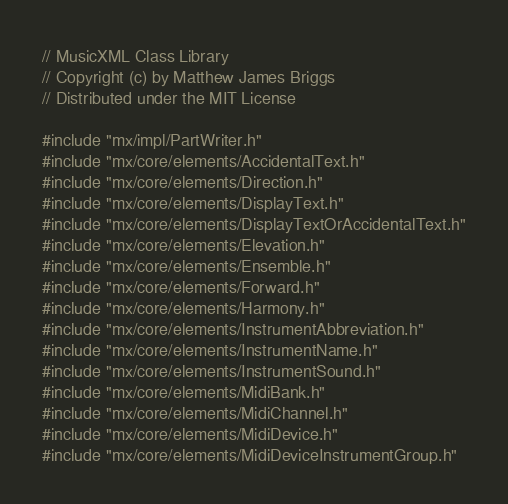<code> <loc_0><loc_0><loc_500><loc_500><_C++_>// MusicXML Class Library
// Copyright (c) by Matthew James Briggs
// Distributed under the MIT License

#include "mx/impl/PartWriter.h"
#include "mx/core/elements/AccidentalText.h"
#include "mx/core/elements/Direction.h"
#include "mx/core/elements/DisplayText.h"
#include "mx/core/elements/DisplayTextOrAccidentalText.h"
#include "mx/core/elements/Elevation.h"
#include "mx/core/elements/Ensemble.h"
#include "mx/core/elements/Forward.h"
#include "mx/core/elements/Harmony.h"
#include "mx/core/elements/InstrumentAbbreviation.h"
#include "mx/core/elements/InstrumentName.h"
#include "mx/core/elements/InstrumentSound.h"
#include "mx/core/elements/MidiBank.h"
#include "mx/core/elements/MidiChannel.h"
#include "mx/core/elements/MidiDevice.h"
#include "mx/core/elements/MidiDeviceInstrumentGroup.h"</code> 